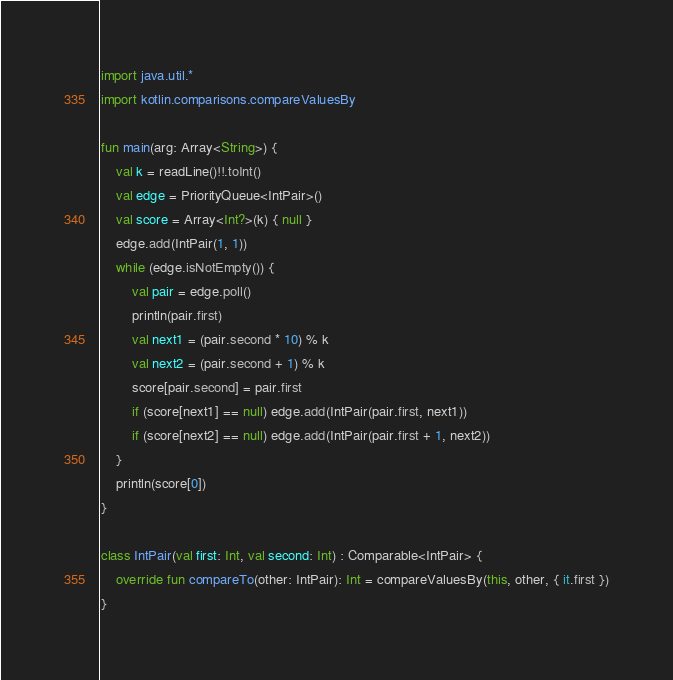<code> <loc_0><loc_0><loc_500><loc_500><_Kotlin_>import java.util.*
import kotlin.comparisons.compareValuesBy

fun main(arg: Array<String>) {
    val k = readLine()!!.toInt()
    val edge = PriorityQueue<IntPair>()
    val score = Array<Int?>(k) { null }
    edge.add(IntPair(1, 1))
    while (edge.isNotEmpty()) {
        val pair = edge.poll()
        println(pair.first)
        val next1 = (pair.second * 10) % k
        val next2 = (pair.second + 1) % k
        score[pair.second] = pair.first
        if (score[next1] == null) edge.add(IntPair(pair.first, next1))
        if (score[next2] == null) edge.add(IntPair(pair.first + 1, next2))
    }
    println(score[0])
}

class IntPair(val first: Int, val second: Int) : Comparable<IntPair> {
    override fun compareTo(other: IntPair): Int = compareValuesBy(this, other, { it.first })
}
</code> 